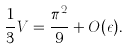Convert formula to latex. <formula><loc_0><loc_0><loc_500><loc_500>\frac { 1 } { 3 } V = \frac { \pi ^ { 2 } } { 9 } + O ( \epsilon ) .</formula> 